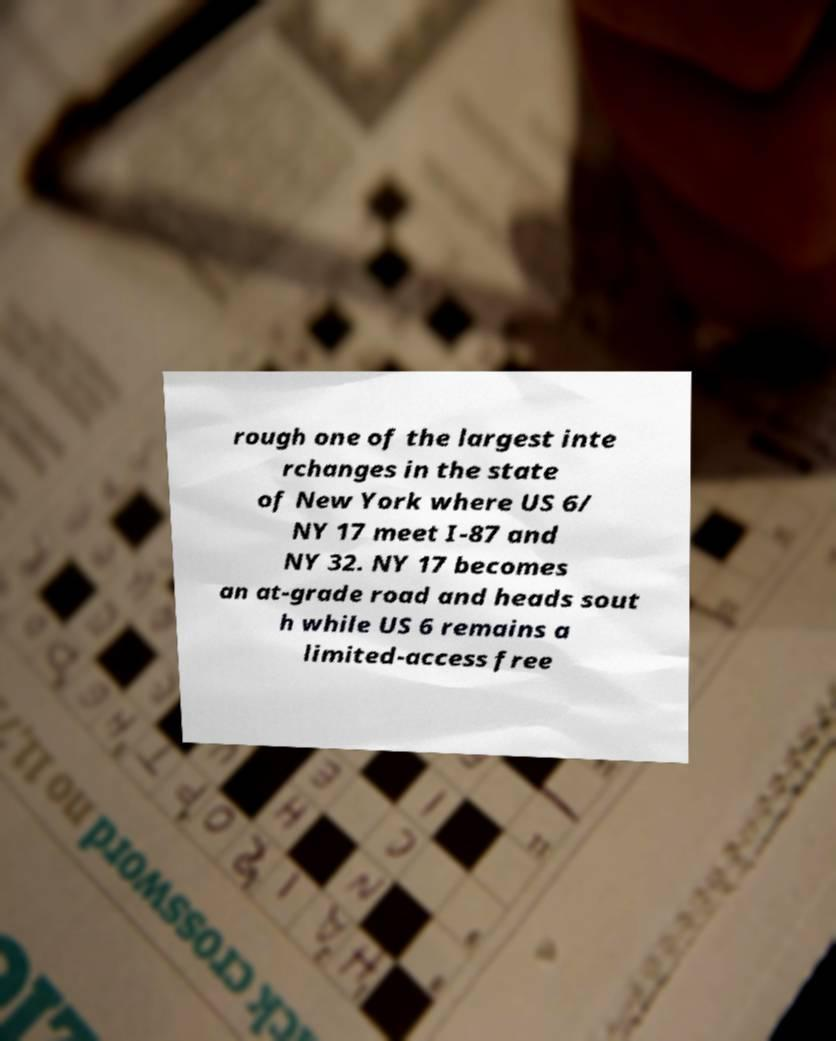Please read and relay the text visible in this image. What does it say? rough one of the largest inte rchanges in the state of New York where US 6/ NY 17 meet I-87 and NY 32. NY 17 becomes an at-grade road and heads sout h while US 6 remains a limited-access free 